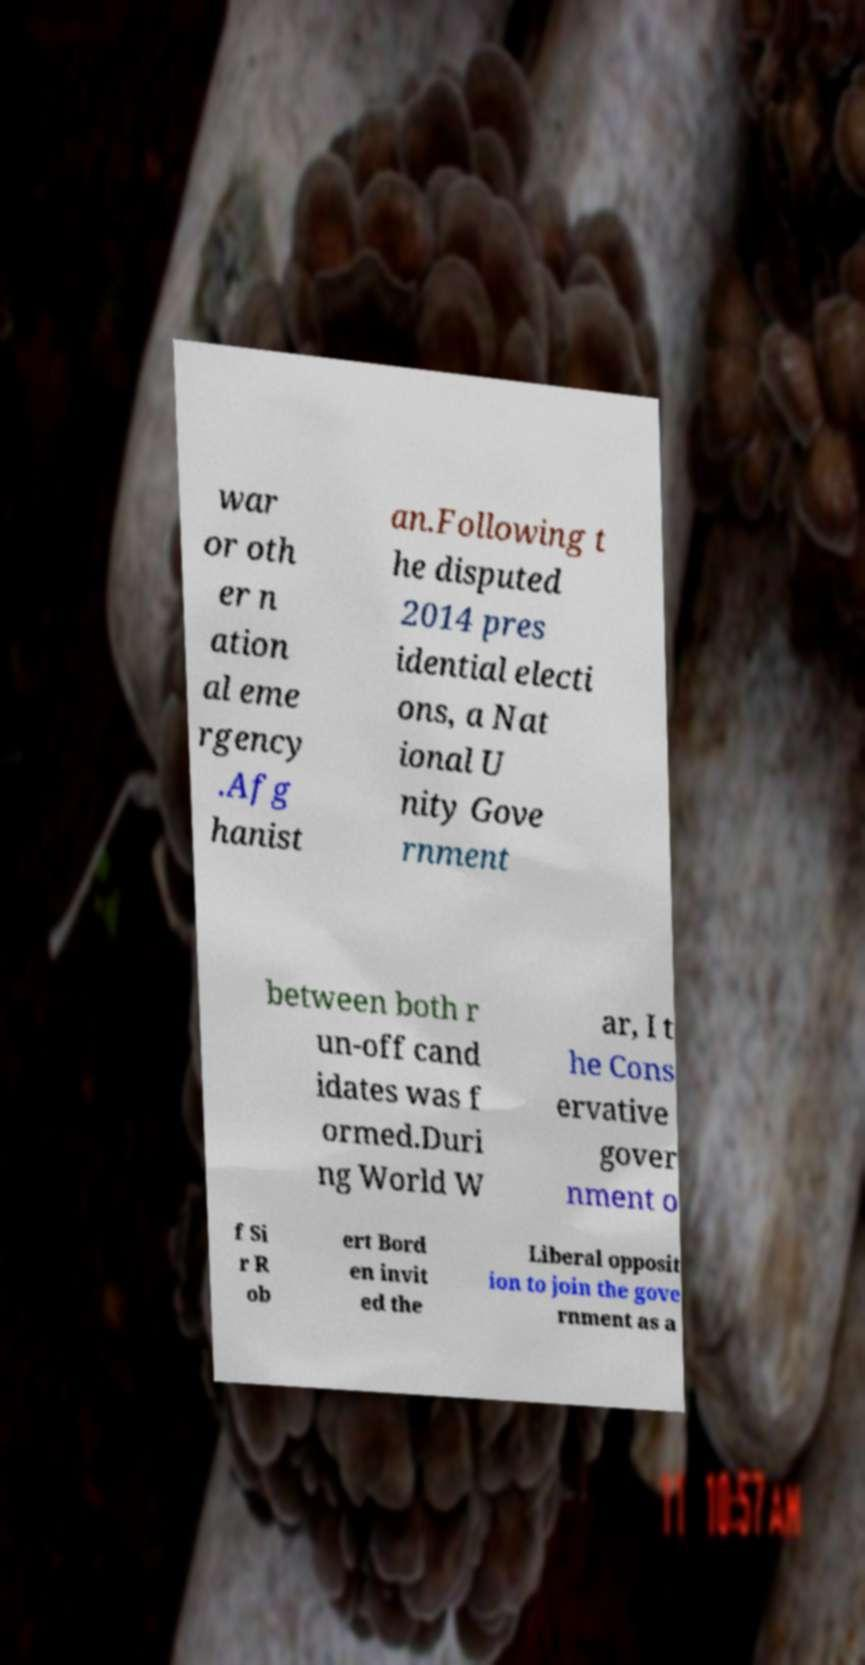I need the written content from this picture converted into text. Can you do that? war or oth er n ation al eme rgency .Afg hanist an.Following t he disputed 2014 pres idential electi ons, a Nat ional U nity Gove rnment between both r un-off cand idates was f ormed.Duri ng World W ar, I t he Cons ervative gover nment o f Si r R ob ert Bord en invit ed the Liberal opposit ion to join the gove rnment as a 